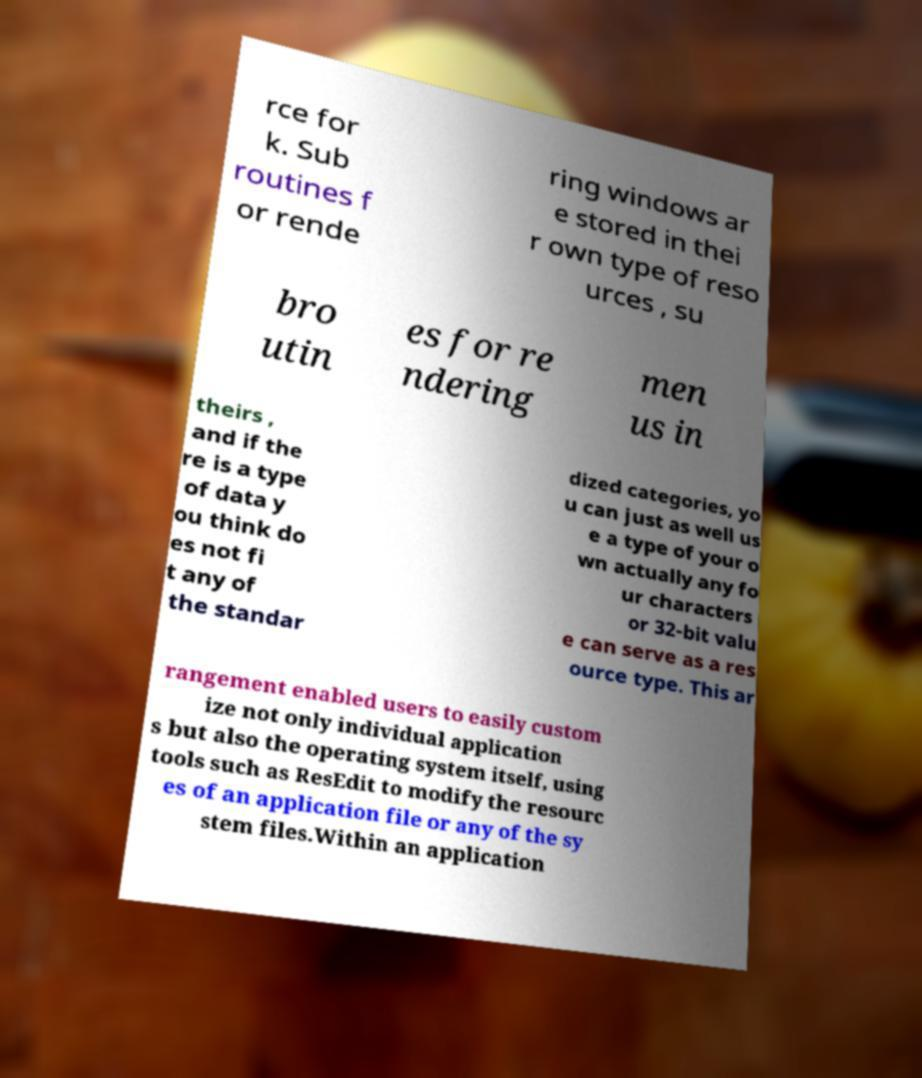Please identify and transcribe the text found in this image. rce for k. Sub routines f or rende ring windows ar e stored in thei r own type of reso urces , su bro utin es for re ndering men us in theirs , and if the re is a type of data y ou think do es not fi t any of the standar dized categories, yo u can just as well us e a type of your o wn actually any fo ur characters or 32-bit valu e can serve as a res ource type. This ar rangement enabled users to easily custom ize not only individual application s but also the operating system itself, using tools such as ResEdit to modify the resourc es of an application file or any of the sy stem files.Within an application 